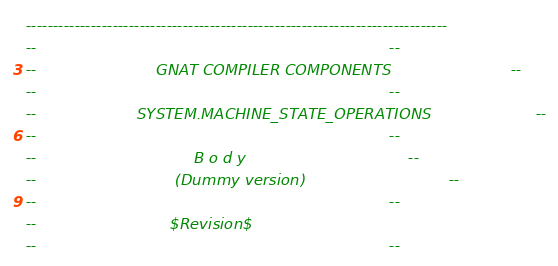<code> <loc_0><loc_0><loc_500><loc_500><_Ada_>------------------------------------------------------------------------------
--                                                                          --
--                         GNAT COMPILER COMPONENTS                         --
--                                                                          --
--                     SYSTEM.MACHINE_STATE_OPERATIONS                      --
--                                                                          --
--                                 B o d y                                  --
--                             (Dummy version)                              --
--                                                                          --
--                            $Revision$
--                                                                          --</code> 